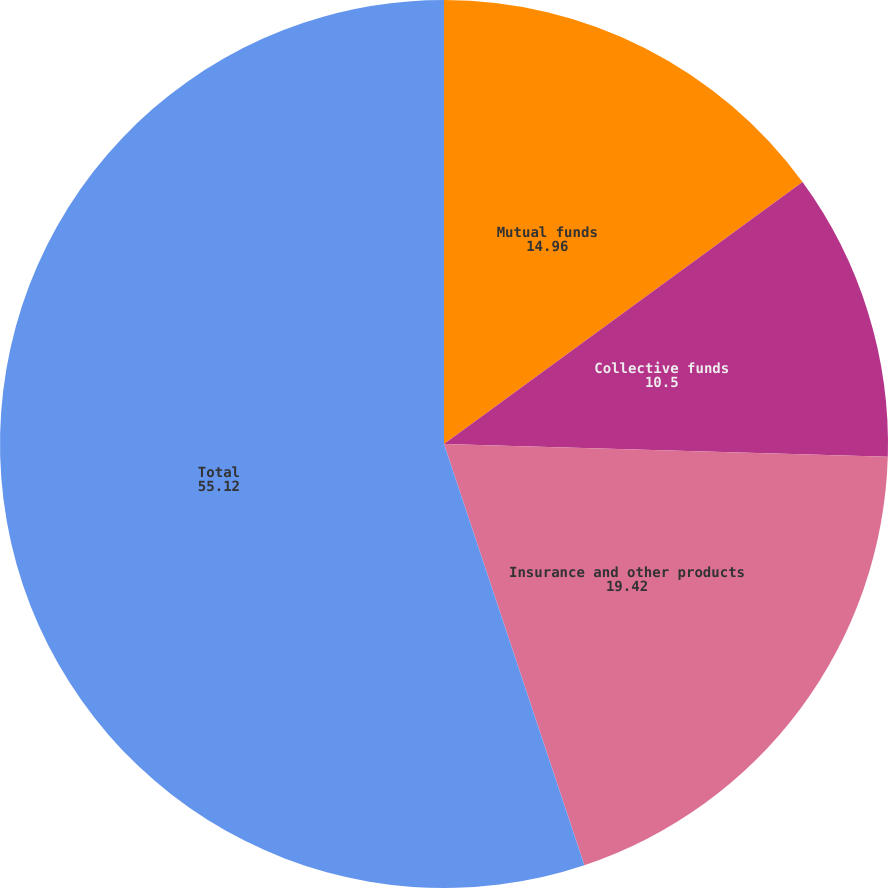Convert chart to OTSL. <chart><loc_0><loc_0><loc_500><loc_500><pie_chart><fcel>Mutual funds<fcel>Collective funds<fcel>Insurance and other products<fcel>Total<nl><fcel>14.96%<fcel>10.5%<fcel>19.42%<fcel>55.12%<nl></chart> 